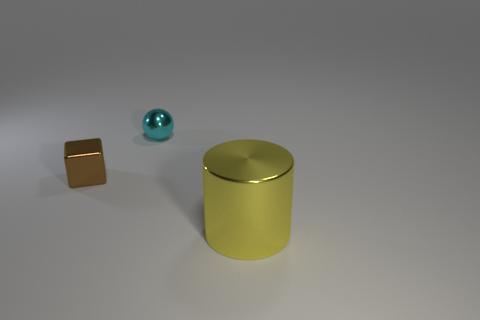Add 1 yellow cylinders. How many objects exist? 4 Subtract all spheres. How many objects are left? 2 Add 3 small brown things. How many small brown things are left? 4 Add 3 big metallic cylinders. How many big metallic cylinders exist? 4 Subtract 1 cyan spheres. How many objects are left? 2 Subtract all metal cubes. Subtract all metallic cubes. How many objects are left? 1 